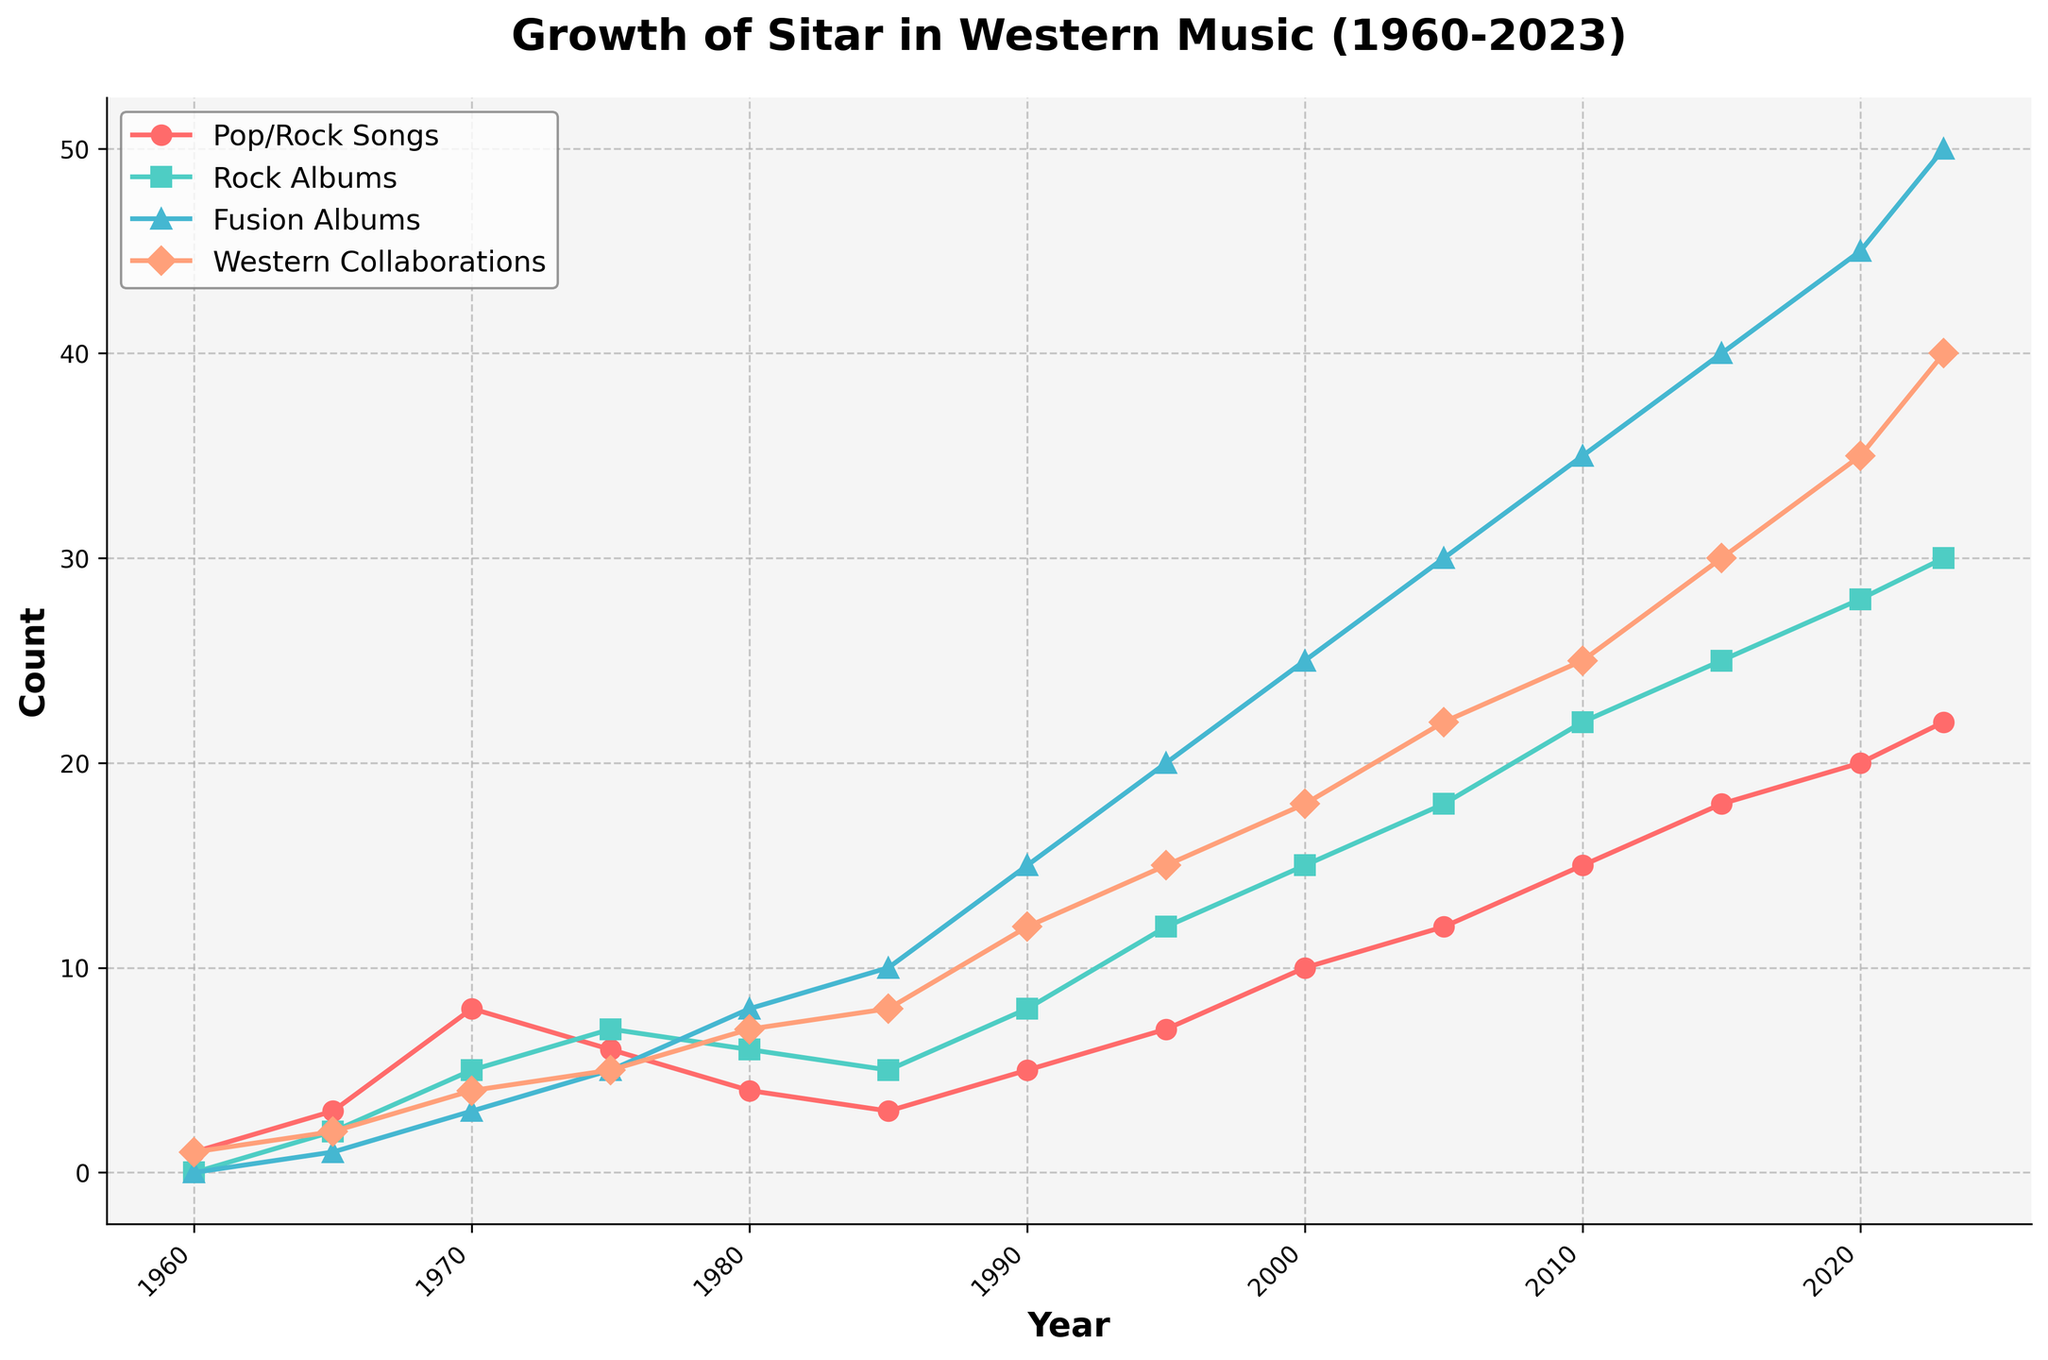What is the trend in the number of Indian Classical Fusion Albums from 1960 to 2023? The number of Indian Classical Fusion Albums steadily increases from 1960 to 2023. This shows a growing interest in fusion music incorporating sitar over the years. In 1960, there were no such albums, but by 2023, the number had risen to 50.
Answer: Steady increase Between which years did the number of Sitar Players in Western Collaborations see the highest increase? By comparing the values between consecutive years, the largest increases occurred between 1985 (8 players) and 1990 (12 players), and between 2015 (30 players) and 2020 (35 players), with an increase of 5 players each.
Answer: 1985-1990 and 2015-2020 How many Mainstream Pop/Rock Songs with Sitar were there in 1990 compared to 1965? Looking at the chart, in 1990, there were 5 songs, and in 1965, there were 3 songs. The increase is thus 5 - 3 = 2 songs more in 1990 than in 1965.
Answer: 2 more songs What was the count for Sitar-Influenced Rock Albums in 1985, and how does it compare to the count in 2005? In 1985, there were 5 Sitar-Influenced Rock Albums and in 2005, there were 18. The count in 2005 is more than three times higher than in 1985.
Answer: 13 more albums Around which year did all four categories first exceed a count of 10? Examining the figure, around the year 1990, the counts for Mainstream Pop/Rock Songs with Sitar (5), Sitar-Influenced Rock Albums (8), Indian Classical Fusion Albums (15), and Sitar Players in Western Collaborations (12) all exceeded 10 for the first time.
Answer: 1990 Which category shows the most significant growth from 1960 to 2023? The Indian Classical Fusion Albums category shows the most significant growth, going from 0 in 1960 to 50 in 2023. This demonstrates an increasing trend over the years, marking the highest count among all categories in 2023.
Answer: Indian Classical Fusion Albums What can be inferred about the popularity of Sitar in Western Pop/Rock songs between 1980 and 2000? From 1980, the count starts at 4 and gradually increases, reaching 7 in 1995 and ultimately 10 in 2000. This implies a growing adoption of the sitar in Western music within this timeframe.
Answer: Increasing popularity How does the number of Mainstream Pop/Rock Songs with Sitar in 2023 compare to that of Sitar Players in Western Collaborations? In 2023, the number of Mainstream Pop/Rock Songs with Sitar is 22, while the number of Sitar Players in Western Collaborations is 40. The latter is significantly higher.
Answer: Collaborations have 18 more How much did the number of Indian Classical Fusion Albums increase from 2010 to 2023? In 2010, there were 35 Indian Classical Fusion Albums, and in 2023, there are 50, showing an increase of 50 - 35 = 15 albums.
Answer: 15 albums Which category had the highest count in 2000, and what was the value? The Indian Classical Fusion Albums category had the highest count in 2000 with 25 albums.
Answer: Indian Classical Fusion Albums, 25 